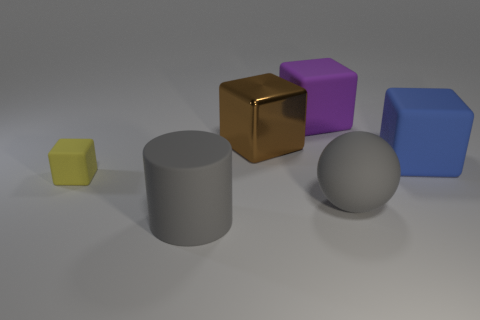Is the material of the large block that is in front of the shiny block the same as the purple thing?
Give a very brief answer. Yes. What number of gray objects are either large cubes or rubber cylinders?
Offer a very short reply. 1. Is there a small object that has the same color as the ball?
Keep it short and to the point. No. Are there any small yellow objects that have the same material as the tiny yellow block?
Your response must be concise. No. What is the shape of the big matte object that is both behind the yellow rubber block and in front of the purple cube?
Keep it short and to the point. Cube. What number of small things are gray rubber balls or yellow metallic spheres?
Your answer should be very brief. 0. What material is the blue block?
Your answer should be very brief. Rubber. What number of other objects are there of the same shape as the large blue object?
Your answer should be compact. 3. What is the size of the gray rubber sphere?
Provide a short and direct response. Large. There is a object that is both in front of the tiny yellow block and behind the matte cylinder; what size is it?
Make the answer very short. Large. 